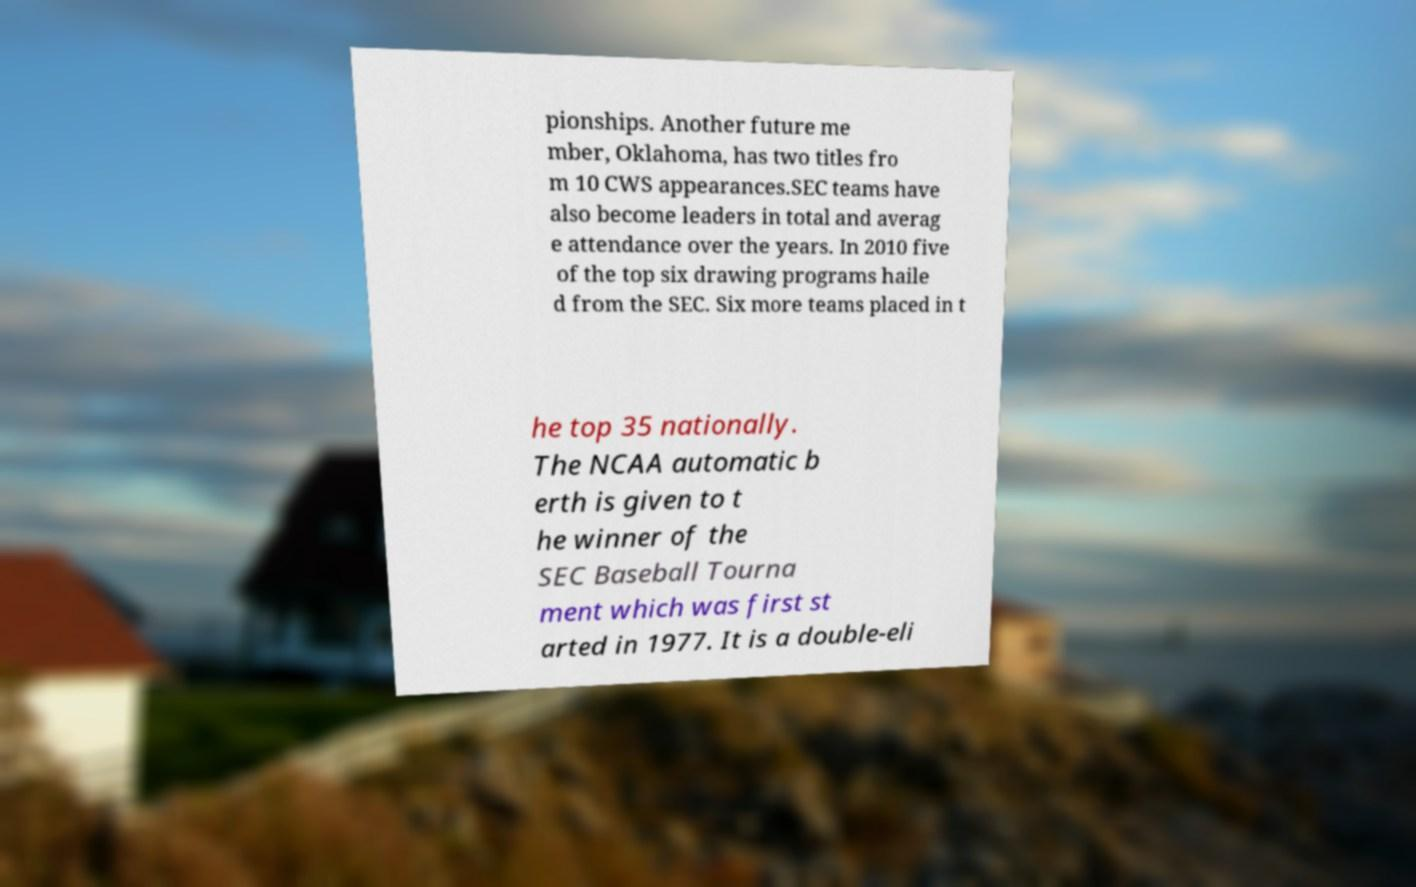Can you read and provide the text displayed in the image?This photo seems to have some interesting text. Can you extract and type it out for me? pionships. Another future me mber, Oklahoma, has two titles fro m 10 CWS appearances.SEC teams have also become leaders in total and averag e attendance over the years. In 2010 five of the top six drawing programs haile d from the SEC. Six more teams placed in t he top 35 nationally. The NCAA automatic b erth is given to t he winner of the SEC Baseball Tourna ment which was first st arted in 1977. It is a double-eli 